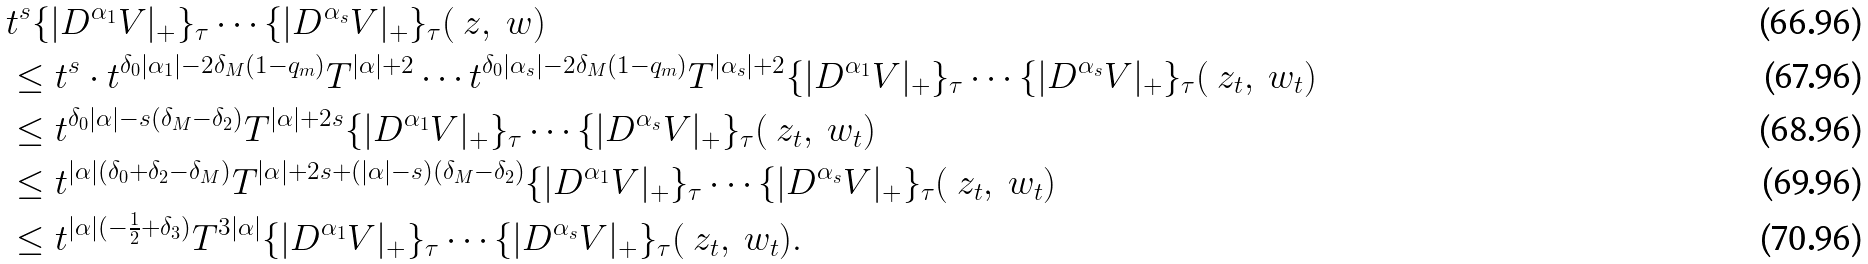<formula> <loc_0><loc_0><loc_500><loc_500>& t ^ { s } \{ | D ^ { \alpha _ { 1 } } V | _ { + } \} _ { \tau } \cdots \{ | D ^ { \alpha _ { s } } V | _ { + } \} _ { \tau } ( \ z , \ w ) \\ & \leq t ^ { s } \cdot t ^ { \delta _ { 0 } | \alpha _ { 1 } | - 2 \delta _ { M } ( 1 - q _ { m } ) } T ^ { | \alpha | + 2 } \cdots t ^ { \delta _ { 0 } | \alpha _ { s } | - 2 \delta _ { M } ( 1 - q _ { m } ) } T ^ { | \alpha _ { s } | + 2 } \{ | D ^ { \alpha _ { 1 } } V | _ { + } \} _ { \tau } \cdots \{ | D ^ { \alpha _ { s } } V | _ { + } \} _ { \tau } ( \ z _ { t } , \ w _ { t } ) \\ & \leq t ^ { \delta _ { 0 } | \alpha | - s ( \delta _ { M } - \delta _ { 2 } ) } T ^ { | \alpha | + 2 s } \{ | D ^ { \alpha _ { 1 } } V | _ { + } \} _ { \tau } \cdots \{ | D ^ { \alpha _ { s } } V | _ { + } \} _ { \tau } ( \ z _ { t } , \ w _ { t } ) \\ & \leq t ^ { | \alpha | ( \delta _ { 0 } + \delta _ { 2 } - \delta _ { M } ) } T ^ { | \alpha | + 2 s + ( | \alpha | - s ) ( \delta _ { M } - \delta _ { 2 } ) } \{ | D ^ { \alpha _ { 1 } } V | _ { + } \} _ { \tau } \cdots \{ | D ^ { \alpha _ { s } } V | _ { + } \} _ { \tau } ( \ z _ { t } , \ w _ { t } ) \\ & \leq t ^ { | \alpha | ( - \frac { 1 } { 2 } + \delta _ { 3 } ) } T ^ { 3 | \alpha | } \{ | D ^ { \alpha _ { 1 } } V | _ { + } \} _ { \tau } \cdots \{ | D ^ { \alpha _ { s } } V | _ { + } \} _ { \tau } ( \ z _ { t } , \ w _ { t } ) .</formula> 